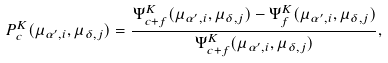<formula> <loc_0><loc_0><loc_500><loc_500>P ^ { K } _ { c } ( \mu _ { \alpha ^ { \prime } , i } , \mu _ { \delta , j } ) = \frac { \Psi ^ { K } _ { c + f } ( \mu _ { \alpha ^ { \prime } , i } , \mu _ { \delta , j } ) - \Psi ^ { K } _ { f } ( \mu _ { \alpha ^ { \prime } , i } , \mu _ { \delta , j } ) } { \Psi ^ { K } _ { c + f } ( \mu _ { \alpha ^ { \prime } , i } , \mu _ { \delta , j } ) } ,</formula> 